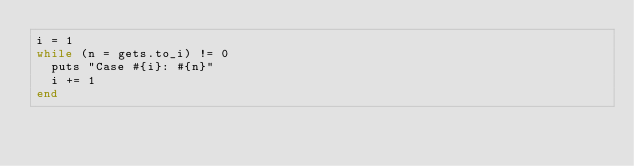Convert code to text. <code><loc_0><loc_0><loc_500><loc_500><_Ruby_>i = 1
while (n = gets.to_i) != 0
  puts "Case #{i}: #{n}"
  i += 1
end
</code> 